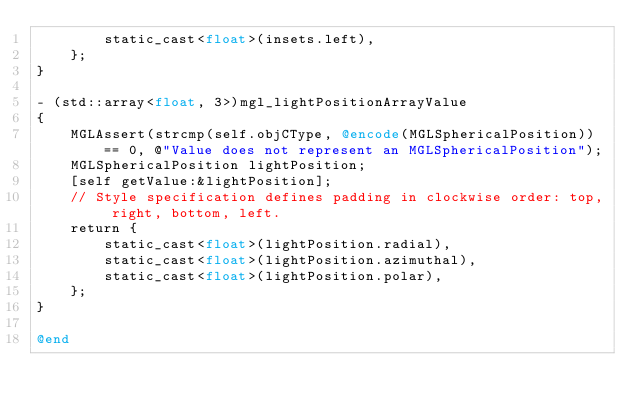Convert code to text. <code><loc_0><loc_0><loc_500><loc_500><_ObjectiveC_>        static_cast<float>(insets.left),
    };
}

- (std::array<float, 3>)mgl_lightPositionArrayValue
{
    MGLAssert(strcmp(self.objCType, @encode(MGLSphericalPosition)) == 0, @"Value does not represent an MGLSphericalPosition");
    MGLSphericalPosition lightPosition;
    [self getValue:&lightPosition];
    // Style specification defines padding in clockwise order: top, right, bottom, left.
    return {
        static_cast<float>(lightPosition.radial),
        static_cast<float>(lightPosition.azimuthal),
        static_cast<float>(lightPosition.polar),
    };
}

@end
</code> 